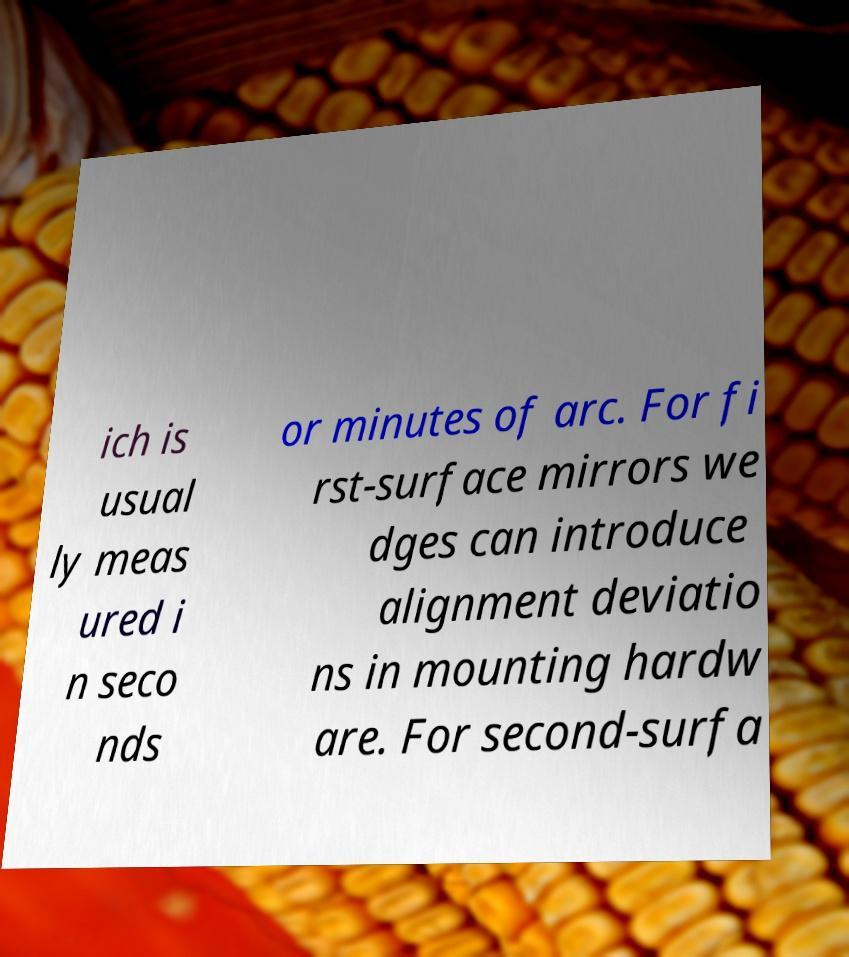What messages or text are displayed in this image? I need them in a readable, typed format. ich is usual ly meas ured i n seco nds or minutes of arc. For fi rst-surface mirrors we dges can introduce alignment deviatio ns in mounting hardw are. For second-surfa 